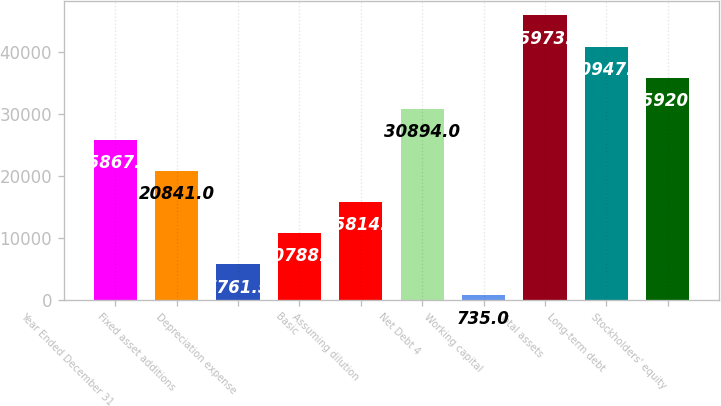Convert chart. <chart><loc_0><loc_0><loc_500><loc_500><bar_chart><fcel>Year Ended December 31<fcel>Fixed asset additions<fcel>Depreciation expense<fcel>Basic<fcel>Assuming dilution<fcel>Net Debt 4<fcel>Working capital<fcel>Total assets<fcel>Long-term debt<fcel>Stockholders' equity<nl><fcel>25867.5<fcel>20841<fcel>5761.5<fcel>10788<fcel>15814.5<fcel>30894<fcel>735<fcel>45973.5<fcel>40947<fcel>35920.5<nl></chart> 